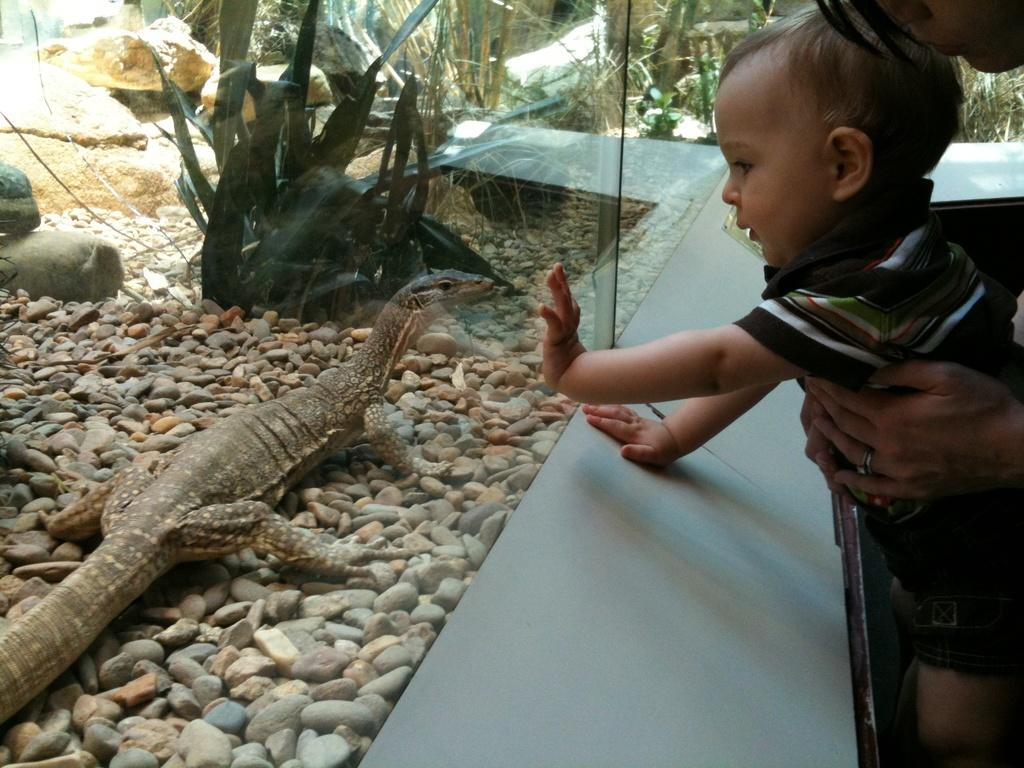What is the main subject of the image? There is a person in the image. What is the person doing in the image? The person is standing and looking at a lizard. What is in front of the person? There is a glass with stones and plants in front of the person. What other object can be seen in the image? There is a blue cardboard box in the image. Can you tell me how many apples are on the slope in the image? There are no apples or slopes present in the image. What type of squirrel can be seen climbing the blue cardboard box in the image? There is no squirrel present in the image, and the blue cardboard box is not depicted as having any slopes. 